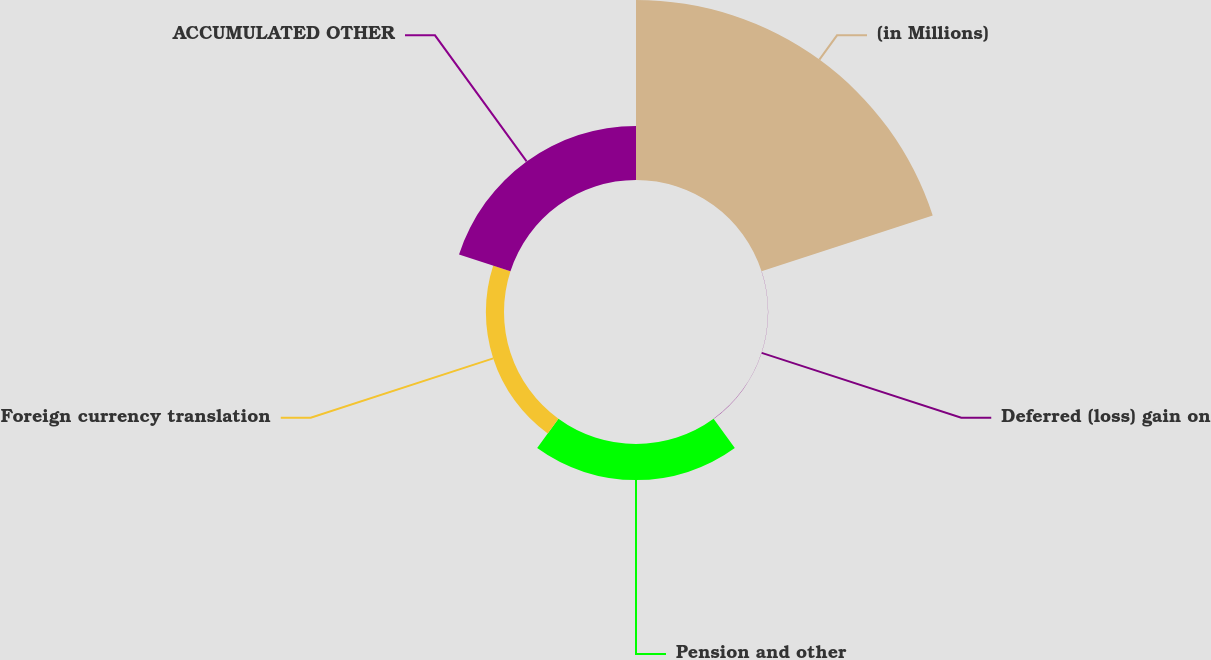Convert chart to OTSL. <chart><loc_0><loc_0><loc_500><loc_500><pie_chart><fcel>(in Millions)<fcel>Deferred (loss) gain on<fcel>Pension and other<fcel>Foreign currency translation<fcel>ACCUMULATED OTHER<nl><fcel>62.4%<fcel>0.05%<fcel>12.52%<fcel>6.28%<fcel>18.75%<nl></chart> 